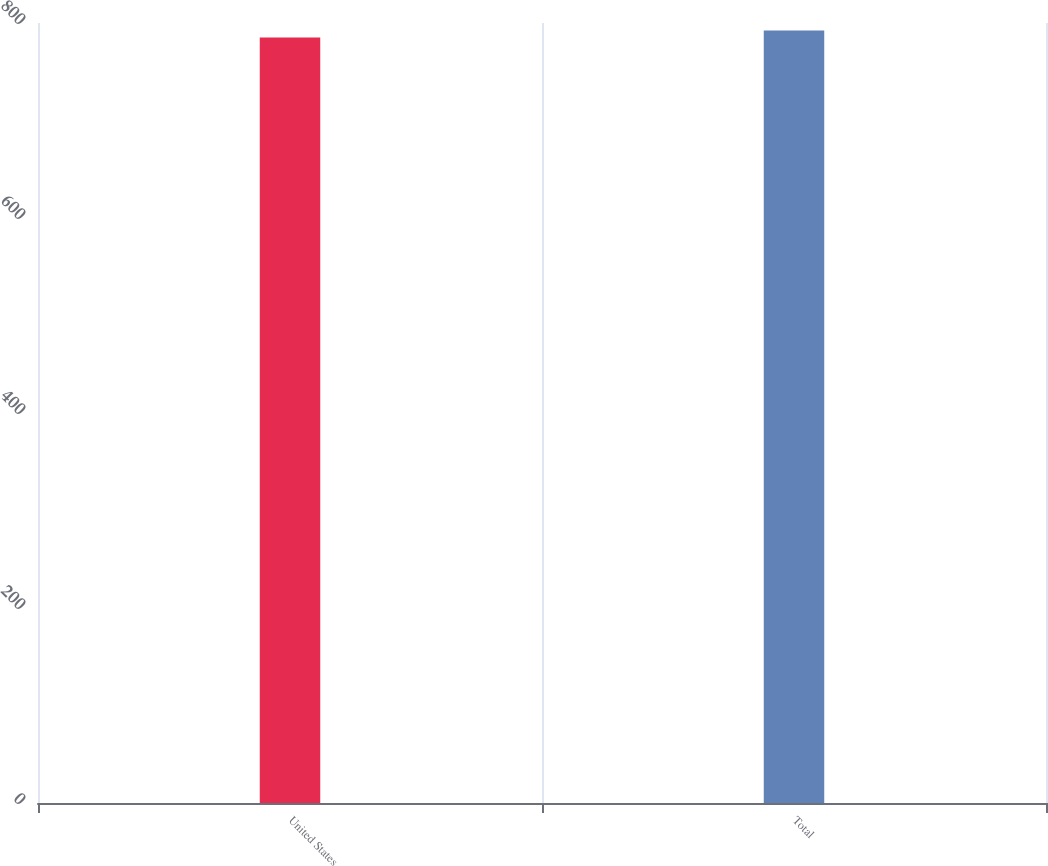Convert chart to OTSL. <chart><loc_0><loc_0><loc_500><loc_500><bar_chart><fcel>United States<fcel>Total<nl><fcel>785.2<fcel>792.3<nl></chart> 